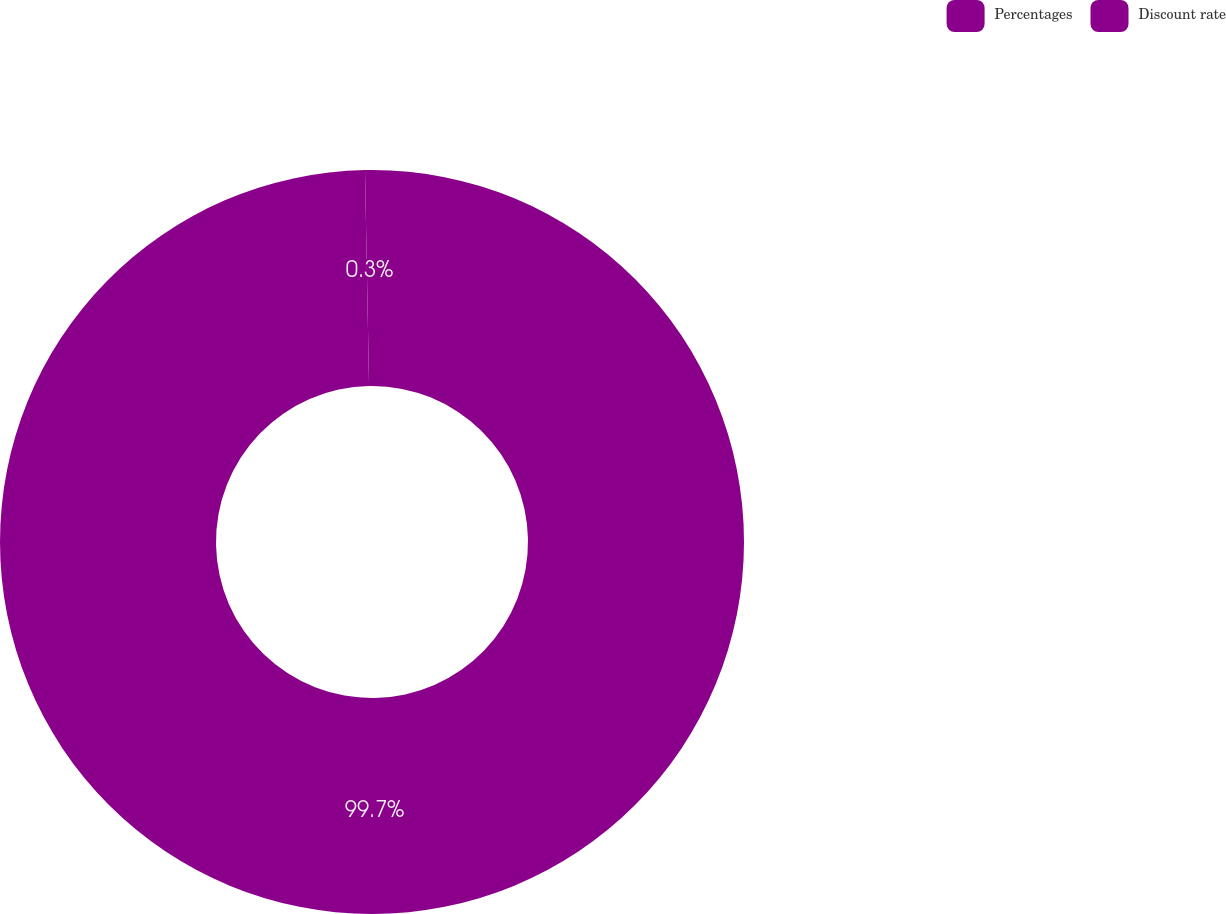<chart> <loc_0><loc_0><loc_500><loc_500><pie_chart><fcel>Percentages<fcel>Discount rate<nl><fcel>99.7%<fcel>0.3%<nl></chart> 